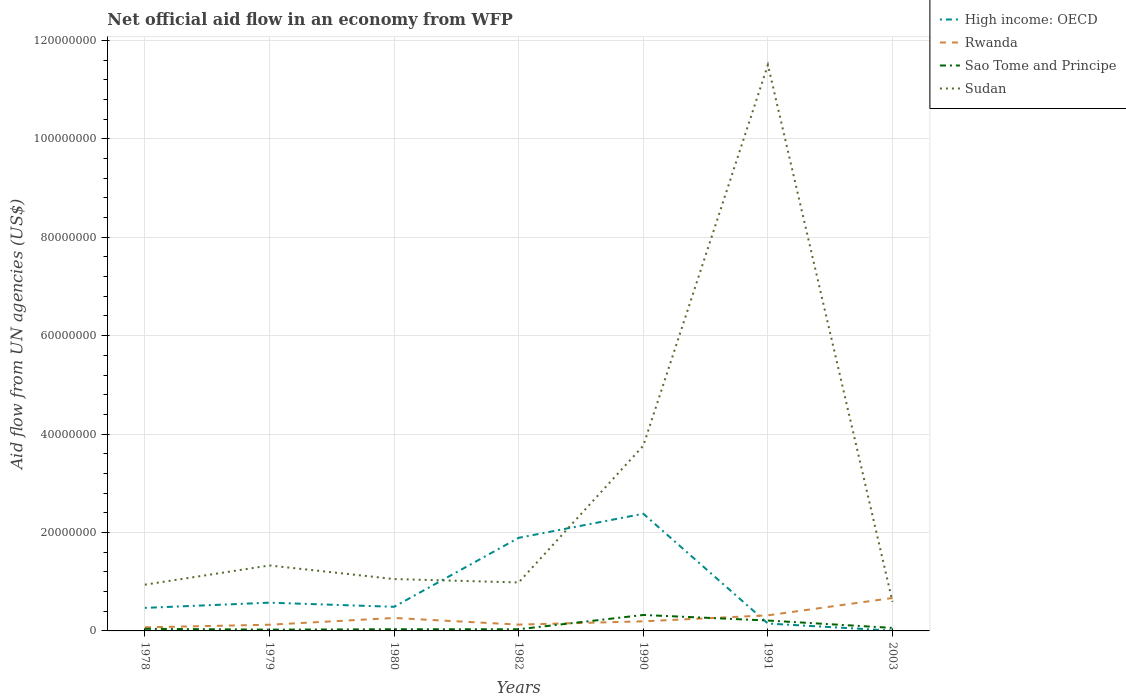How many different coloured lines are there?
Provide a short and direct response. 4. Does the line corresponding to Rwanda intersect with the line corresponding to High income: OECD?
Keep it short and to the point. Yes. Is the number of lines equal to the number of legend labels?
Your answer should be very brief. Yes. Across all years, what is the maximum net official aid flow in Sudan?
Provide a succinct answer. 5.92e+06. In which year was the net official aid flow in Sao Tome and Principe maximum?
Provide a short and direct response. 1979. What is the total net official aid flow in Rwanda in the graph?
Provide a succinct answer. -1.22e+06. What is the difference between the highest and the second highest net official aid flow in High income: OECD?
Ensure brevity in your answer.  2.38e+07. Is the net official aid flow in Sudan strictly greater than the net official aid flow in Sao Tome and Principe over the years?
Make the answer very short. No. How many lines are there?
Give a very brief answer. 4. How many years are there in the graph?
Offer a terse response. 7. Does the graph contain any zero values?
Give a very brief answer. No. Does the graph contain grids?
Offer a terse response. Yes. How many legend labels are there?
Ensure brevity in your answer.  4. How are the legend labels stacked?
Give a very brief answer. Vertical. What is the title of the graph?
Make the answer very short. Net official aid flow in an economy from WFP. What is the label or title of the X-axis?
Offer a very short reply. Years. What is the label or title of the Y-axis?
Provide a short and direct response. Aid flow from UN agencies (US$). What is the Aid flow from UN agencies (US$) in High income: OECD in 1978?
Offer a very short reply. 4.68e+06. What is the Aid flow from UN agencies (US$) of Rwanda in 1978?
Provide a short and direct response. 7.30e+05. What is the Aid flow from UN agencies (US$) in Sao Tome and Principe in 1978?
Keep it short and to the point. 4.30e+05. What is the Aid flow from UN agencies (US$) in Sudan in 1978?
Provide a succinct answer. 9.40e+06. What is the Aid flow from UN agencies (US$) in High income: OECD in 1979?
Your response must be concise. 5.74e+06. What is the Aid flow from UN agencies (US$) in Rwanda in 1979?
Your answer should be compact. 1.26e+06. What is the Aid flow from UN agencies (US$) in Sudan in 1979?
Your answer should be compact. 1.33e+07. What is the Aid flow from UN agencies (US$) of High income: OECD in 1980?
Keep it short and to the point. 4.90e+06. What is the Aid flow from UN agencies (US$) of Rwanda in 1980?
Offer a terse response. 2.63e+06. What is the Aid flow from UN agencies (US$) of Sudan in 1980?
Offer a very short reply. 1.05e+07. What is the Aid flow from UN agencies (US$) in High income: OECD in 1982?
Your answer should be very brief. 1.89e+07. What is the Aid flow from UN agencies (US$) of Rwanda in 1982?
Keep it short and to the point. 1.28e+06. What is the Aid flow from UN agencies (US$) in Sao Tome and Principe in 1982?
Keep it short and to the point. 3.40e+05. What is the Aid flow from UN agencies (US$) in Sudan in 1982?
Give a very brief answer. 9.85e+06. What is the Aid flow from UN agencies (US$) in High income: OECD in 1990?
Offer a terse response. 2.38e+07. What is the Aid flow from UN agencies (US$) in Rwanda in 1990?
Your answer should be very brief. 1.95e+06. What is the Aid flow from UN agencies (US$) of Sao Tome and Principe in 1990?
Keep it short and to the point. 3.24e+06. What is the Aid flow from UN agencies (US$) in Sudan in 1990?
Your answer should be compact. 3.76e+07. What is the Aid flow from UN agencies (US$) in High income: OECD in 1991?
Your response must be concise. 1.50e+06. What is the Aid flow from UN agencies (US$) in Rwanda in 1991?
Your response must be concise. 3.17e+06. What is the Aid flow from UN agencies (US$) in Sao Tome and Principe in 1991?
Make the answer very short. 2.11e+06. What is the Aid flow from UN agencies (US$) of Sudan in 1991?
Offer a very short reply. 1.15e+08. What is the Aid flow from UN agencies (US$) of Rwanda in 2003?
Your answer should be compact. 6.69e+06. What is the Aid flow from UN agencies (US$) of Sudan in 2003?
Give a very brief answer. 5.92e+06. Across all years, what is the maximum Aid flow from UN agencies (US$) of High income: OECD?
Provide a succinct answer. 2.38e+07. Across all years, what is the maximum Aid flow from UN agencies (US$) in Rwanda?
Ensure brevity in your answer.  6.69e+06. Across all years, what is the maximum Aid flow from UN agencies (US$) of Sao Tome and Principe?
Your answer should be very brief. 3.24e+06. Across all years, what is the maximum Aid flow from UN agencies (US$) in Sudan?
Give a very brief answer. 1.15e+08. Across all years, what is the minimum Aid flow from UN agencies (US$) in Rwanda?
Provide a short and direct response. 7.30e+05. Across all years, what is the minimum Aid flow from UN agencies (US$) of Sao Tome and Principe?
Offer a very short reply. 2.60e+05. Across all years, what is the minimum Aid flow from UN agencies (US$) in Sudan?
Give a very brief answer. 5.92e+06. What is the total Aid flow from UN agencies (US$) in High income: OECD in the graph?
Give a very brief answer. 5.96e+07. What is the total Aid flow from UN agencies (US$) of Rwanda in the graph?
Your response must be concise. 1.77e+07. What is the total Aid flow from UN agencies (US$) in Sao Tome and Principe in the graph?
Your answer should be very brief. 7.33e+06. What is the total Aid flow from UN agencies (US$) of Sudan in the graph?
Offer a terse response. 2.02e+08. What is the difference between the Aid flow from UN agencies (US$) of High income: OECD in 1978 and that in 1979?
Keep it short and to the point. -1.06e+06. What is the difference between the Aid flow from UN agencies (US$) of Rwanda in 1978 and that in 1979?
Offer a terse response. -5.30e+05. What is the difference between the Aid flow from UN agencies (US$) of Sudan in 1978 and that in 1979?
Ensure brevity in your answer.  -3.90e+06. What is the difference between the Aid flow from UN agencies (US$) in Rwanda in 1978 and that in 1980?
Provide a short and direct response. -1.90e+06. What is the difference between the Aid flow from UN agencies (US$) in Sao Tome and Principe in 1978 and that in 1980?
Ensure brevity in your answer.  9.00e+04. What is the difference between the Aid flow from UN agencies (US$) of Sudan in 1978 and that in 1980?
Offer a terse response. -1.14e+06. What is the difference between the Aid flow from UN agencies (US$) in High income: OECD in 1978 and that in 1982?
Give a very brief answer. -1.42e+07. What is the difference between the Aid flow from UN agencies (US$) in Rwanda in 1978 and that in 1982?
Keep it short and to the point. -5.50e+05. What is the difference between the Aid flow from UN agencies (US$) of Sudan in 1978 and that in 1982?
Your answer should be very brief. -4.50e+05. What is the difference between the Aid flow from UN agencies (US$) of High income: OECD in 1978 and that in 1990?
Keep it short and to the point. -1.91e+07. What is the difference between the Aid flow from UN agencies (US$) in Rwanda in 1978 and that in 1990?
Ensure brevity in your answer.  -1.22e+06. What is the difference between the Aid flow from UN agencies (US$) in Sao Tome and Principe in 1978 and that in 1990?
Ensure brevity in your answer.  -2.81e+06. What is the difference between the Aid flow from UN agencies (US$) of Sudan in 1978 and that in 1990?
Provide a succinct answer. -2.82e+07. What is the difference between the Aid flow from UN agencies (US$) in High income: OECD in 1978 and that in 1991?
Your answer should be very brief. 3.18e+06. What is the difference between the Aid flow from UN agencies (US$) in Rwanda in 1978 and that in 1991?
Give a very brief answer. -2.44e+06. What is the difference between the Aid flow from UN agencies (US$) of Sao Tome and Principe in 1978 and that in 1991?
Provide a short and direct response. -1.68e+06. What is the difference between the Aid flow from UN agencies (US$) in Sudan in 1978 and that in 1991?
Provide a succinct answer. -1.06e+08. What is the difference between the Aid flow from UN agencies (US$) of High income: OECD in 1978 and that in 2003?
Give a very brief answer. 4.62e+06. What is the difference between the Aid flow from UN agencies (US$) of Rwanda in 1978 and that in 2003?
Provide a short and direct response. -5.96e+06. What is the difference between the Aid flow from UN agencies (US$) of Sao Tome and Principe in 1978 and that in 2003?
Give a very brief answer. -1.80e+05. What is the difference between the Aid flow from UN agencies (US$) of Sudan in 1978 and that in 2003?
Your answer should be compact. 3.48e+06. What is the difference between the Aid flow from UN agencies (US$) in High income: OECD in 1979 and that in 1980?
Offer a terse response. 8.40e+05. What is the difference between the Aid flow from UN agencies (US$) of Rwanda in 1979 and that in 1980?
Your answer should be compact. -1.37e+06. What is the difference between the Aid flow from UN agencies (US$) in Sudan in 1979 and that in 1980?
Provide a succinct answer. 2.76e+06. What is the difference between the Aid flow from UN agencies (US$) of High income: OECD in 1979 and that in 1982?
Offer a very short reply. -1.32e+07. What is the difference between the Aid flow from UN agencies (US$) of Sudan in 1979 and that in 1982?
Offer a terse response. 3.45e+06. What is the difference between the Aid flow from UN agencies (US$) of High income: OECD in 1979 and that in 1990?
Your answer should be very brief. -1.81e+07. What is the difference between the Aid flow from UN agencies (US$) of Rwanda in 1979 and that in 1990?
Your answer should be compact. -6.90e+05. What is the difference between the Aid flow from UN agencies (US$) of Sao Tome and Principe in 1979 and that in 1990?
Offer a very short reply. -2.98e+06. What is the difference between the Aid flow from UN agencies (US$) of Sudan in 1979 and that in 1990?
Ensure brevity in your answer.  -2.43e+07. What is the difference between the Aid flow from UN agencies (US$) of High income: OECD in 1979 and that in 1991?
Provide a succinct answer. 4.24e+06. What is the difference between the Aid flow from UN agencies (US$) in Rwanda in 1979 and that in 1991?
Ensure brevity in your answer.  -1.91e+06. What is the difference between the Aid flow from UN agencies (US$) of Sao Tome and Principe in 1979 and that in 1991?
Give a very brief answer. -1.85e+06. What is the difference between the Aid flow from UN agencies (US$) in Sudan in 1979 and that in 1991?
Keep it short and to the point. -1.02e+08. What is the difference between the Aid flow from UN agencies (US$) of High income: OECD in 1979 and that in 2003?
Your answer should be compact. 5.68e+06. What is the difference between the Aid flow from UN agencies (US$) in Rwanda in 1979 and that in 2003?
Your answer should be compact. -5.43e+06. What is the difference between the Aid flow from UN agencies (US$) of Sao Tome and Principe in 1979 and that in 2003?
Your answer should be very brief. -3.50e+05. What is the difference between the Aid flow from UN agencies (US$) in Sudan in 1979 and that in 2003?
Your response must be concise. 7.38e+06. What is the difference between the Aid flow from UN agencies (US$) in High income: OECD in 1980 and that in 1982?
Provide a short and direct response. -1.40e+07. What is the difference between the Aid flow from UN agencies (US$) in Rwanda in 1980 and that in 1982?
Your answer should be very brief. 1.35e+06. What is the difference between the Aid flow from UN agencies (US$) in Sao Tome and Principe in 1980 and that in 1982?
Provide a succinct answer. 0. What is the difference between the Aid flow from UN agencies (US$) in Sudan in 1980 and that in 1982?
Give a very brief answer. 6.90e+05. What is the difference between the Aid flow from UN agencies (US$) in High income: OECD in 1980 and that in 1990?
Keep it short and to the point. -1.89e+07. What is the difference between the Aid flow from UN agencies (US$) of Rwanda in 1980 and that in 1990?
Your answer should be very brief. 6.80e+05. What is the difference between the Aid flow from UN agencies (US$) in Sao Tome and Principe in 1980 and that in 1990?
Keep it short and to the point. -2.90e+06. What is the difference between the Aid flow from UN agencies (US$) of Sudan in 1980 and that in 1990?
Provide a succinct answer. -2.71e+07. What is the difference between the Aid flow from UN agencies (US$) in High income: OECD in 1980 and that in 1991?
Offer a very short reply. 3.40e+06. What is the difference between the Aid flow from UN agencies (US$) of Rwanda in 1980 and that in 1991?
Your response must be concise. -5.40e+05. What is the difference between the Aid flow from UN agencies (US$) in Sao Tome and Principe in 1980 and that in 1991?
Your answer should be compact. -1.77e+06. What is the difference between the Aid flow from UN agencies (US$) of Sudan in 1980 and that in 1991?
Your answer should be very brief. -1.04e+08. What is the difference between the Aid flow from UN agencies (US$) of High income: OECD in 1980 and that in 2003?
Your answer should be compact. 4.84e+06. What is the difference between the Aid flow from UN agencies (US$) in Rwanda in 1980 and that in 2003?
Make the answer very short. -4.06e+06. What is the difference between the Aid flow from UN agencies (US$) in Sudan in 1980 and that in 2003?
Your answer should be compact. 4.62e+06. What is the difference between the Aid flow from UN agencies (US$) in High income: OECD in 1982 and that in 1990?
Give a very brief answer. -4.89e+06. What is the difference between the Aid flow from UN agencies (US$) in Rwanda in 1982 and that in 1990?
Provide a short and direct response. -6.70e+05. What is the difference between the Aid flow from UN agencies (US$) of Sao Tome and Principe in 1982 and that in 1990?
Give a very brief answer. -2.90e+06. What is the difference between the Aid flow from UN agencies (US$) in Sudan in 1982 and that in 1990?
Give a very brief answer. -2.78e+07. What is the difference between the Aid flow from UN agencies (US$) of High income: OECD in 1982 and that in 1991?
Your answer should be compact. 1.74e+07. What is the difference between the Aid flow from UN agencies (US$) in Rwanda in 1982 and that in 1991?
Your response must be concise. -1.89e+06. What is the difference between the Aid flow from UN agencies (US$) of Sao Tome and Principe in 1982 and that in 1991?
Your answer should be compact. -1.77e+06. What is the difference between the Aid flow from UN agencies (US$) in Sudan in 1982 and that in 1991?
Your response must be concise. -1.05e+08. What is the difference between the Aid flow from UN agencies (US$) of High income: OECD in 1982 and that in 2003?
Provide a short and direct response. 1.89e+07. What is the difference between the Aid flow from UN agencies (US$) in Rwanda in 1982 and that in 2003?
Your answer should be very brief. -5.41e+06. What is the difference between the Aid flow from UN agencies (US$) in Sudan in 1982 and that in 2003?
Offer a terse response. 3.93e+06. What is the difference between the Aid flow from UN agencies (US$) in High income: OECD in 1990 and that in 1991?
Keep it short and to the point. 2.23e+07. What is the difference between the Aid flow from UN agencies (US$) in Rwanda in 1990 and that in 1991?
Offer a terse response. -1.22e+06. What is the difference between the Aid flow from UN agencies (US$) in Sao Tome and Principe in 1990 and that in 1991?
Offer a very short reply. 1.13e+06. What is the difference between the Aid flow from UN agencies (US$) in Sudan in 1990 and that in 1991?
Your response must be concise. -7.74e+07. What is the difference between the Aid flow from UN agencies (US$) of High income: OECD in 1990 and that in 2003?
Ensure brevity in your answer.  2.38e+07. What is the difference between the Aid flow from UN agencies (US$) in Rwanda in 1990 and that in 2003?
Make the answer very short. -4.74e+06. What is the difference between the Aid flow from UN agencies (US$) in Sao Tome and Principe in 1990 and that in 2003?
Your answer should be compact. 2.63e+06. What is the difference between the Aid flow from UN agencies (US$) of Sudan in 1990 and that in 2003?
Ensure brevity in your answer.  3.17e+07. What is the difference between the Aid flow from UN agencies (US$) in High income: OECD in 1991 and that in 2003?
Provide a succinct answer. 1.44e+06. What is the difference between the Aid flow from UN agencies (US$) in Rwanda in 1991 and that in 2003?
Offer a very short reply. -3.52e+06. What is the difference between the Aid flow from UN agencies (US$) of Sao Tome and Principe in 1991 and that in 2003?
Your answer should be very brief. 1.50e+06. What is the difference between the Aid flow from UN agencies (US$) in Sudan in 1991 and that in 2003?
Keep it short and to the point. 1.09e+08. What is the difference between the Aid flow from UN agencies (US$) of High income: OECD in 1978 and the Aid flow from UN agencies (US$) of Rwanda in 1979?
Make the answer very short. 3.42e+06. What is the difference between the Aid flow from UN agencies (US$) of High income: OECD in 1978 and the Aid flow from UN agencies (US$) of Sao Tome and Principe in 1979?
Ensure brevity in your answer.  4.42e+06. What is the difference between the Aid flow from UN agencies (US$) in High income: OECD in 1978 and the Aid flow from UN agencies (US$) in Sudan in 1979?
Provide a succinct answer. -8.62e+06. What is the difference between the Aid flow from UN agencies (US$) in Rwanda in 1978 and the Aid flow from UN agencies (US$) in Sudan in 1979?
Your answer should be compact. -1.26e+07. What is the difference between the Aid flow from UN agencies (US$) in Sao Tome and Principe in 1978 and the Aid flow from UN agencies (US$) in Sudan in 1979?
Your answer should be very brief. -1.29e+07. What is the difference between the Aid flow from UN agencies (US$) in High income: OECD in 1978 and the Aid flow from UN agencies (US$) in Rwanda in 1980?
Your response must be concise. 2.05e+06. What is the difference between the Aid flow from UN agencies (US$) in High income: OECD in 1978 and the Aid flow from UN agencies (US$) in Sao Tome and Principe in 1980?
Your answer should be very brief. 4.34e+06. What is the difference between the Aid flow from UN agencies (US$) of High income: OECD in 1978 and the Aid flow from UN agencies (US$) of Sudan in 1980?
Ensure brevity in your answer.  -5.86e+06. What is the difference between the Aid flow from UN agencies (US$) of Rwanda in 1978 and the Aid flow from UN agencies (US$) of Sao Tome and Principe in 1980?
Give a very brief answer. 3.90e+05. What is the difference between the Aid flow from UN agencies (US$) in Rwanda in 1978 and the Aid flow from UN agencies (US$) in Sudan in 1980?
Provide a succinct answer. -9.81e+06. What is the difference between the Aid flow from UN agencies (US$) of Sao Tome and Principe in 1978 and the Aid flow from UN agencies (US$) of Sudan in 1980?
Offer a very short reply. -1.01e+07. What is the difference between the Aid flow from UN agencies (US$) of High income: OECD in 1978 and the Aid flow from UN agencies (US$) of Rwanda in 1982?
Your response must be concise. 3.40e+06. What is the difference between the Aid flow from UN agencies (US$) in High income: OECD in 1978 and the Aid flow from UN agencies (US$) in Sao Tome and Principe in 1982?
Offer a very short reply. 4.34e+06. What is the difference between the Aid flow from UN agencies (US$) in High income: OECD in 1978 and the Aid flow from UN agencies (US$) in Sudan in 1982?
Make the answer very short. -5.17e+06. What is the difference between the Aid flow from UN agencies (US$) in Rwanda in 1978 and the Aid flow from UN agencies (US$) in Sudan in 1982?
Your response must be concise. -9.12e+06. What is the difference between the Aid flow from UN agencies (US$) in Sao Tome and Principe in 1978 and the Aid flow from UN agencies (US$) in Sudan in 1982?
Provide a succinct answer. -9.42e+06. What is the difference between the Aid flow from UN agencies (US$) in High income: OECD in 1978 and the Aid flow from UN agencies (US$) in Rwanda in 1990?
Provide a succinct answer. 2.73e+06. What is the difference between the Aid flow from UN agencies (US$) in High income: OECD in 1978 and the Aid flow from UN agencies (US$) in Sao Tome and Principe in 1990?
Give a very brief answer. 1.44e+06. What is the difference between the Aid flow from UN agencies (US$) of High income: OECD in 1978 and the Aid flow from UN agencies (US$) of Sudan in 1990?
Ensure brevity in your answer.  -3.30e+07. What is the difference between the Aid flow from UN agencies (US$) of Rwanda in 1978 and the Aid flow from UN agencies (US$) of Sao Tome and Principe in 1990?
Give a very brief answer. -2.51e+06. What is the difference between the Aid flow from UN agencies (US$) of Rwanda in 1978 and the Aid flow from UN agencies (US$) of Sudan in 1990?
Your response must be concise. -3.69e+07. What is the difference between the Aid flow from UN agencies (US$) of Sao Tome and Principe in 1978 and the Aid flow from UN agencies (US$) of Sudan in 1990?
Give a very brief answer. -3.72e+07. What is the difference between the Aid flow from UN agencies (US$) of High income: OECD in 1978 and the Aid flow from UN agencies (US$) of Rwanda in 1991?
Offer a terse response. 1.51e+06. What is the difference between the Aid flow from UN agencies (US$) in High income: OECD in 1978 and the Aid flow from UN agencies (US$) in Sao Tome and Principe in 1991?
Provide a short and direct response. 2.57e+06. What is the difference between the Aid flow from UN agencies (US$) in High income: OECD in 1978 and the Aid flow from UN agencies (US$) in Sudan in 1991?
Make the answer very short. -1.10e+08. What is the difference between the Aid flow from UN agencies (US$) in Rwanda in 1978 and the Aid flow from UN agencies (US$) in Sao Tome and Principe in 1991?
Your answer should be very brief. -1.38e+06. What is the difference between the Aid flow from UN agencies (US$) in Rwanda in 1978 and the Aid flow from UN agencies (US$) in Sudan in 1991?
Provide a short and direct response. -1.14e+08. What is the difference between the Aid flow from UN agencies (US$) of Sao Tome and Principe in 1978 and the Aid flow from UN agencies (US$) of Sudan in 1991?
Your response must be concise. -1.15e+08. What is the difference between the Aid flow from UN agencies (US$) of High income: OECD in 1978 and the Aid flow from UN agencies (US$) of Rwanda in 2003?
Your answer should be compact. -2.01e+06. What is the difference between the Aid flow from UN agencies (US$) in High income: OECD in 1978 and the Aid flow from UN agencies (US$) in Sao Tome and Principe in 2003?
Give a very brief answer. 4.07e+06. What is the difference between the Aid flow from UN agencies (US$) in High income: OECD in 1978 and the Aid flow from UN agencies (US$) in Sudan in 2003?
Your answer should be compact. -1.24e+06. What is the difference between the Aid flow from UN agencies (US$) in Rwanda in 1978 and the Aid flow from UN agencies (US$) in Sao Tome and Principe in 2003?
Offer a very short reply. 1.20e+05. What is the difference between the Aid flow from UN agencies (US$) in Rwanda in 1978 and the Aid flow from UN agencies (US$) in Sudan in 2003?
Your response must be concise. -5.19e+06. What is the difference between the Aid flow from UN agencies (US$) of Sao Tome and Principe in 1978 and the Aid flow from UN agencies (US$) of Sudan in 2003?
Offer a very short reply. -5.49e+06. What is the difference between the Aid flow from UN agencies (US$) of High income: OECD in 1979 and the Aid flow from UN agencies (US$) of Rwanda in 1980?
Provide a succinct answer. 3.11e+06. What is the difference between the Aid flow from UN agencies (US$) in High income: OECD in 1979 and the Aid flow from UN agencies (US$) in Sao Tome and Principe in 1980?
Make the answer very short. 5.40e+06. What is the difference between the Aid flow from UN agencies (US$) of High income: OECD in 1979 and the Aid flow from UN agencies (US$) of Sudan in 1980?
Provide a succinct answer. -4.80e+06. What is the difference between the Aid flow from UN agencies (US$) in Rwanda in 1979 and the Aid flow from UN agencies (US$) in Sao Tome and Principe in 1980?
Give a very brief answer. 9.20e+05. What is the difference between the Aid flow from UN agencies (US$) of Rwanda in 1979 and the Aid flow from UN agencies (US$) of Sudan in 1980?
Give a very brief answer. -9.28e+06. What is the difference between the Aid flow from UN agencies (US$) in Sao Tome and Principe in 1979 and the Aid flow from UN agencies (US$) in Sudan in 1980?
Make the answer very short. -1.03e+07. What is the difference between the Aid flow from UN agencies (US$) in High income: OECD in 1979 and the Aid flow from UN agencies (US$) in Rwanda in 1982?
Give a very brief answer. 4.46e+06. What is the difference between the Aid flow from UN agencies (US$) in High income: OECD in 1979 and the Aid flow from UN agencies (US$) in Sao Tome and Principe in 1982?
Your answer should be compact. 5.40e+06. What is the difference between the Aid flow from UN agencies (US$) of High income: OECD in 1979 and the Aid flow from UN agencies (US$) of Sudan in 1982?
Keep it short and to the point. -4.11e+06. What is the difference between the Aid flow from UN agencies (US$) in Rwanda in 1979 and the Aid flow from UN agencies (US$) in Sao Tome and Principe in 1982?
Your response must be concise. 9.20e+05. What is the difference between the Aid flow from UN agencies (US$) in Rwanda in 1979 and the Aid flow from UN agencies (US$) in Sudan in 1982?
Ensure brevity in your answer.  -8.59e+06. What is the difference between the Aid flow from UN agencies (US$) of Sao Tome and Principe in 1979 and the Aid flow from UN agencies (US$) of Sudan in 1982?
Keep it short and to the point. -9.59e+06. What is the difference between the Aid flow from UN agencies (US$) in High income: OECD in 1979 and the Aid flow from UN agencies (US$) in Rwanda in 1990?
Ensure brevity in your answer.  3.79e+06. What is the difference between the Aid flow from UN agencies (US$) in High income: OECD in 1979 and the Aid flow from UN agencies (US$) in Sao Tome and Principe in 1990?
Your answer should be compact. 2.50e+06. What is the difference between the Aid flow from UN agencies (US$) in High income: OECD in 1979 and the Aid flow from UN agencies (US$) in Sudan in 1990?
Your answer should be very brief. -3.19e+07. What is the difference between the Aid flow from UN agencies (US$) of Rwanda in 1979 and the Aid flow from UN agencies (US$) of Sao Tome and Principe in 1990?
Your response must be concise. -1.98e+06. What is the difference between the Aid flow from UN agencies (US$) of Rwanda in 1979 and the Aid flow from UN agencies (US$) of Sudan in 1990?
Your answer should be very brief. -3.64e+07. What is the difference between the Aid flow from UN agencies (US$) of Sao Tome and Principe in 1979 and the Aid flow from UN agencies (US$) of Sudan in 1990?
Your answer should be very brief. -3.74e+07. What is the difference between the Aid flow from UN agencies (US$) in High income: OECD in 1979 and the Aid flow from UN agencies (US$) in Rwanda in 1991?
Your answer should be compact. 2.57e+06. What is the difference between the Aid flow from UN agencies (US$) in High income: OECD in 1979 and the Aid flow from UN agencies (US$) in Sao Tome and Principe in 1991?
Keep it short and to the point. 3.63e+06. What is the difference between the Aid flow from UN agencies (US$) of High income: OECD in 1979 and the Aid flow from UN agencies (US$) of Sudan in 1991?
Your response must be concise. -1.09e+08. What is the difference between the Aid flow from UN agencies (US$) in Rwanda in 1979 and the Aid flow from UN agencies (US$) in Sao Tome and Principe in 1991?
Provide a short and direct response. -8.50e+05. What is the difference between the Aid flow from UN agencies (US$) of Rwanda in 1979 and the Aid flow from UN agencies (US$) of Sudan in 1991?
Give a very brief answer. -1.14e+08. What is the difference between the Aid flow from UN agencies (US$) in Sao Tome and Principe in 1979 and the Aid flow from UN agencies (US$) in Sudan in 1991?
Your answer should be compact. -1.15e+08. What is the difference between the Aid flow from UN agencies (US$) in High income: OECD in 1979 and the Aid flow from UN agencies (US$) in Rwanda in 2003?
Ensure brevity in your answer.  -9.50e+05. What is the difference between the Aid flow from UN agencies (US$) of High income: OECD in 1979 and the Aid flow from UN agencies (US$) of Sao Tome and Principe in 2003?
Keep it short and to the point. 5.13e+06. What is the difference between the Aid flow from UN agencies (US$) of High income: OECD in 1979 and the Aid flow from UN agencies (US$) of Sudan in 2003?
Your answer should be compact. -1.80e+05. What is the difference between the Aid flow from UN agencies (US$) in Rwanda in 1979 and the Aid flow from UN agencies (US$) in Sao Tome and Principe in 2003?
Keep it short and to the point. 6.50e+05. What is the difference between the Aid flow from UN agencies (US$) in Rwanda in 1979 and the Aid flow from UN agencies (US$) in Sudan in 2003?
Your response must be concise. -4.66e+06. What is the difference between the Aid flow from UN agencies (US$) of Sao Tome and Principe in 1979 and the Aid flow from UN agencies (US$) of Sudan in 2003?
Give a very brief answer. -5.66e+06. What is the difference between the Aid flow from UN agencies (US$) of High income: OECD in 1980 and the Aid flow from UN agencies (US$) of Rwanda in 1982?
Your answer should be very brief. 3.62e+06. What is the difference between the Aid flow from UN agencies (US$) in High income: OECD in 1980 and the Aid flow from UN agencies (US$) in Sao Tome and Principe in 1982?
Keep it short and to the point. 4.56e+06. What is the difference between the Aid flow from UN agencies (US$) in High income: OECD in 1980 and the Aid flow from UN agencies (US$) in Sudan in 1982?
Your response must be concise. -4.95e+06. What is the difference between the Aid flow from UN agencies (US$) in Rwanda in 1980 and the Aid flow from UN agencies (US$) in Sao Tome and Principe in 1982?
Your answer should be compact. 2.29e+06. What is the difference between the Aid flow from UN agencies (US$) in Rwanda in 1980 and the Aid flow from UN agencies (US$) in Sudan in 1982?
Provide a succinct answer. -7.22e+06. What is the difference between the Aid flow from UN agencies (US$) of Sao Tome and Principe in 1980 and the Aid flow from UN agencies (US$) of Sudan in 1982?
Provide a succinct answer. -9.51e+06. What is the difference between the Aid flow from UN agencies (US$) in High income: OECD in 1980 and the Aid flow from UN agencies (US$) in Rwanda in 1990?
Provide a short and direct response. 2.95e+06. What is the difference between the Aid flow from UN agencies (US$) in High income: OECD in 1980 and the Aid flow from UN agencies (US$) in Sao Tome and Principe in 1990?
Provide a succinct answer. 1.66e+06. What is the difference between the Aid flow from UN agencies (US$) in High income: OECD in 1980 and the Aid flow from UN agencies (US$) in Sudan in 1990?
Provide a short and direct response. -3.27e+07. What is the difference between the Aid flow from UN agencies (US$) in Rwanda in 1980 and the Aid flow from UN agencies (US$) in Sao Tome and Principe in 1990?
Offer a terse response. -6.10e+05. What is the difference between the Aid flow from UN agencies (US$) of Rwanda in 1980 and the Aid flow from UN agencies (US$) of Sudan in 1990?
Your response must be concise. -3.50e+07. What is the difference between the Aid flow from UN agencies (US$) of Sao Tome and Principe in 1980 and the Aid flow from UN agencies (US$) of Sudan in 1990?
Your answer should be compact. -3.73e+07. What is the difference between the Aid flow from UN agencies (US$) of High income: OECD in 1980 and the Aid flow from UN agencies (US$) of Rwanda in 1991?
Give a very brief answer. 1.73e+06. What is the difference between the Aid flow from UN agencies (US$) of High income: OECD in 1980 and the Aid flow from UN agencies (US$) of Sao Tome and Principe in 1991?
Ensure brevity in your answer.  2.79e+06. What is the difference between the Aid flow from UN agencies (US$) in High income: OECD in 1980 and the Aid flow from UN agencies (US$) in Sudan in 1991?
Ensure brevity in your answer.  -1.10e+08. What is the difference between the Aid flow from UN agencies (US$) of Rwanda in 1980 and the Aid flow from UN agencies (US$) of Sao Tome and Principe in 1991?
Provide a short and direct response. 5.20e+05. What is the difference between the Aid flow from UN agencies (US$) of Rwanda in 1980 and the Aid flow from UN agencies (US$) of Sudan in 1991?
Ensure brevity in your answer.  -1.12e+08. What is the difference between the Aid flow from UN agencies (US$) of Sao Tome and Principe in 1980 and the Aid flow from UN agencies (US$) of Sudan in 1991?
Your answer should be compact. -1.15e+08. What is the difference between the Aid flow from UN agencies (US$) in High income: OECD in 1980 and the Aid flow from UN agencies (US$) in Rwanda in 2003?
Provide a succinct answer. -1.79e+06. What is the difference between the Aid flow from UN agencies (US$) of High income: OECD in 1980 and the Aid flow from UN agencies (US$) of Sao Tome and Principe in 2003?
Offer a terse response. 4.29e+06. What is the difference between the Aid flow from UN agencies (US$) of High income: OECD in 1980 and the Aid flow from UN agencies (US$) of Sudan in 2003?
Keep it short and to the point. -1.02e+06. What is the difference between the Aid flow from UN agencies (US$) of Rwanda in 1980 and the Aid flow from UN agencies (US$) of Sao Tome and Principe in 2003?
Give a very brief answer. 2.02e+06. What is the difference between the Aid flow from UN agencies (US$) in Rwanda in 1980 and the Aid flow from UN agencies (US$) in Sudan in 2003?
Ensure brevity in your answer.  -3.29e+06. What is the difference between the Aid flow from UN agencies (US$) of Sao Tome and Principe in 1980 and the Aid flow from UN agencies (US$) of Sudan in 2003?
Ensure brevity in your answer.  -5.58e+06. What is the difference between the Aid flow from UN agencies (US$) of High income: OECD in 1982 and the Aid flow from UN agencies (US$) of Rwanda in 1990?
Keep it short and to the point. 1.70e+07. What is the difference between the Aid flow from UN agencies (US$) of High income: OECD in 1982 and the Aid flow from UN agencies (US$) of Sao Tome and Principe in 1990?
Make the answer very short. 1.57e+07. What is the difference between the Aid flow from UN agencies (US$) in High income: OECD in 1982 and the Aid flow from UN agencies (US$) in Sudan in 1990?
Offer a terse response. -1.87e+07. What is the difference between the Aid flow from UN agencies (US$) of Rwanda in 1982 and the Aid flow from UN agencies (US$) of Sao Tome and Principe in 1990?
Make the answer very short. -1.96e+06. What is the difference between the Aid flow from UN agencies (US$) of Rwanda in 1982 and the Aid flow from UN agencies (US$) of Sudan in 1990?
Give a very brief answer. -3.64e+07. What is the difference between the Aid flow from UN agencies (US$) of Sao Tome and Principe in 1982 and the Aid flow from UN agencies (US$) of Sudan in 1990?
Provide a short and direct response. -3.73e+07. What is the difference between the Aid flow from UN agencies (US$) in High income: OECD in 1982 and the Aid flow from UN agencies (US$) in Rwanda in 1991?
Your answer should be very brief. 1.58e+07. What is the difference between the Aid flow from UN agencies (US$) in High income: OECD in 1982 and the Aid flow from UN agencies (US$) in Sao Tome and Principe in 1991?
Your answer should be very brief. 1.68e+07. What is the difference between the Aid flow from UN agencies (US$) in High income: OECD in 1982 and the Aid flow from UN agencies (US$) in Sudan in 1991?
Your response must be concise. -9.61e+07. What is the difference between the Aid flow from UN agencies (US$) in Rwanda in 1982 and the Aid flow from UN agencies (US$) in Sao Tome and Principe in 1991?
Your answer should be compact. -8.30e+05. What is the difference between the Aid flow from UN agencies (US$) in Rwanda in 1982 and the Aid flow from UN agencies (US$) in Sudan in 1991?
Your response must be concise. -1.14e+08. What is the difference between the Aid flow from UN agencies (US$) of Sao Tome and Principe in 1982 and the Aid flow from UN agencies (US$) of Sudan in 1991?
Keep it short and to the point. -1.15e+08. What is the difference between the Aid flow from UN agencies (US$) in High income: OECD in 1982 and the Aid flow from UN agencies (US$) in Rwanda in 2003?
Your response must be concise. 1.22e+07. What is the difference between the Aid flow from UN agencies (US$) of High income: OECD in 1982 and the Aid flow from UN agencies (US$) of Sao Tome and Principe in 2003?
Offer a very short reply. 1.83e+07. What is the difference between the Aid flow from UN agencies (US$) in High income: OECD in 1982 and the Aid flow from UN agencies (US$) in Sudan in 2003?
Provide a succinct answer. 1.30e+07. What is the difference between the Aid flow from UN agencies (US$) in Rwanda in 1982 and the Aid flow from UN agencies (US$) in Sao Tome and Principe in 2003?
Your response must be concise. 6.70e+05. What is the difference between the Aid flow from UN agencies (US$) in Rwanda in 1982 and the Aid flow from UN agencies (US$) in Sudan in 2003?
Ensure brevity in your answer.  -4.64e+06. What is the difference between the Aid flow from UN agencies (US$) of Sao Tome and Principe in 1982 and the Aid flow from UN agencies (US$) of Sudan in 2003?
Give a very brief answer. -5.58e+06. What is the difference between the Aid flow from UN agencies (US$) in High income: OECD in 1990 and the Aid flow from UN agencies (US$) in Rwanda in 1991?
Your answer should be compact. 2.06e+07. What is the difference between the Aid flow from UN agencies (US$) in High income: OECD in 1990 and the Aid flow from UN agencies (US$) in Sao Tome and Principe in 1991?
Give a very brief answer. 2.17e+07. What is the difference between the Aid flow from UN agencies (US$) in High income: OECD in 1990 and the Aid flow from UN agencies (US$) in Sudan in 1991?
Provide a short and direct response. -9.12e+07. What is the difference between the Aid flow from UN agencies (US$) in Rwanda in 1990 and the Aid flow from UN agencies (US$) in Sao Tome and Principe in 1991?
Provide a short and direct response. -1.60e+05. What is the difference between the Aid flow from UN agencies (US$) of Rwanda in 1990 and the Aid flow from UN agencies (US$) of Sudan in 1991?
Your response must be concise. -1.13e+08. What is the difference between the Aid flow from UN agencies (US$) of Sao Tome and Principe in 1990 and the Aid flow from UN agencies (US$) of Sudan in 1991?
Keep it short and to the point. -1.12e+08. What is the difference between the Aid flow from UN agencies (US$) in High income: OECD in 1990 and the Aid flow from UN agencies (US$) in Rwanda in 2003?
Your answer should be compact. 1.71e+07. What is the difference between the Aid flow from UN agencies (US$) of High income: OECD in 1990 and the Aid flow from UN agencies (US$) of Sao Tome and Principe in 2003?
Make the answer very short. 2.32e+07. What is the difference between the Aid flow from UN agencies (US$) in High income: OECD in 1990 and the Aid flow from UN agencies (US$) in Sudan in 2003?
Provide a succinct answer. 1.79e+07. What is the difference between the Aid flow from UN agencies (US$) of Rwanda in 1990 and the Aid flow from UN agencies (US$) of Sao Tome and Principe in 2003?
Ensure brevity in your answer.  1.34e+06. What is the difference between the Aid flow from UN agencies (US$) in Rwanda in 1990 and the Aid flow from UN agencies (US$) in Sudan in 2003?
Make the answer very short. -3.97e+06. What is the difference between the Aid flow from UN agencies (US$) of Sao Tome and Principe in 1990 and the Aid flow from UN agencies (US$) of Sudan in 2003?
Keep it short and to the point. -2.68e+06. What is the difference between the Aid flow from UN agencies (US$) in High income: OECD in 1991 and the Aid flow from UN agencies (US$) in Rwanda in 2003?
Offer a very short reply. -5.19e+06. What is the difference between the Aid flow from UN agencies (US$) of High income: OECD in 1991 and the Aid flow from UN agencies (US$) of Sao Tome and Principe in 2003?
Your response must be concise. 8.90e+05. What is the difference between the Aid flow from UN agencies (US$) in High income: OECD in 1991 and the Aid flow from UN agencies (US$) in Sudan in 2003?
Your response must be concise. -4.42e+06. What is the difference between the Aid flow from UN agencies (US$) in Rwanda in 1991 and the Aid flow from UN agencies (US$) in Sao Tome and Principe in 2003?
Your answer should be compact. 2.56e+06. What is the difference between the Aid flow from UN agencies (US$) of Rwanda in 1991 and the Aid flow from UN agencies (US$) of Sudan in 2003?
Provide a short and direct response. -2.75e+06. What is the difference between the Aid flow from UN agencies (US$) of Sao Tome and Principe in 1991 and the Aid flow from UN agencies (US$) of Sudan in 2003?
Make the answer very short. -3.81e+06. What is the average Aid flow from UN agencies (US$) in High income: OECD per year?
Your answer should be compact. 8.52e+06. What is the average Aid flow from UN agencies (US$) of Rwanda per year?
Provide a short and direct response. 2.53e+06. What is the average Aid flow from UN agencies (US$) of Sao Tome and Principe per year?
Provide a short and direct response. 1.05e+06. What is the average Aid flow from UN agencies (US$) of Sudan per year?
Ensure brevity in your answer.  2.88e+07. In the year 1978, what is the difference between the Aid flow from UN agencies (US$) of High income: OECD and Aid flow from UN agencies (US$) of Rwanda?
Your answer should be compact. 3.95e+06. In the year 1978, what is the difference between the Aid flow from UN agencies (US$) of High income: OECD and Aid flow from UN agencies (US$) of Sao Tome and Principe?
Provide a succinct answer. 4.25e+06. In the year 1978, what is the difference between the Aid flow from UN agencies (US$) in High income: OECD and Aid flow from UN agencies (US$) in Sudan?
Provide a short and direct response. -4.72e+06. In the year 1978, what is the difference between the Aid flow from UN agencies (US$) of Rwanda and Aid flow from UN agencies (US$) of Sudan?
Offer a very short reply. -8.67e+06. In the year 1978, what is the difference between the Aid flow from UN agencies (US$) in Sao Tome and Principe and Aid flow from UN agencies (US$) in Sudan?
Provide a succinct answer. -8.97e+06. In the year 1979, what is the difference between the Aid flow from UN agencies (US$) of High income: OECD and Aid flow from UN agencies (US$) of Rwanda?
Your response must be concise. 4.48e+06. In the year 1979, what is the difference between the Aid flow from UN agencies (US$) of High income: OECD and Aid flow from UN agencies (US$) of Sao Tome and Principe?
Keep it short and to the point. 5.48e+06. In the year 1979, what is the difference between the Aid flow from UN agencies (US$) of High income: OECD and Aid flow from UN agencies (US$) of Sudan?
Your answer should be compact. -7.56e+06. In the year 1979, what is the difference between the Aid flow from UN agencies (US$) of Rwanda and Aid flow from UN agencies (US$) of Sao Tome and Principe?
Ensure brevity in your answer.  1.00e+06. In the year 1979, what is the difference between the Aid flow from UN agencies (US$) of Rwanda and Aid flow from UN agencies (US$) of Sudan?
Give a very brief answer. -1.20e+07. In the year 1979, what is the difference between the Aid flow from UN agencies (US$) of Sao Tome and Principe and Aid flow from UN agencies (US$) of Sudan?
Your answer should be very brief. -1.30e+07. In the year 1980, what is the difference between the Aid flow from UN agencies (US$) in High income: OECD and Aid flow from UN agencies (US$) in Rwanda?
Keep it short and to the point. 2.27e+06. In the year 1980, what is the difference between the Aid flow from UN agencies (US$) in High income: OECD and Aid flow from UN agencies (US$) in Sao Tome and Principe?
Make the answer very short. 4.56e+06. In the year 1980, what is the difference between the Aid flow from UN agencies (US$) of High income: OECD and Aid flow from UN agencies (US$) of Sudan?
Your answer should be compact. -5.64e+06. In the year 1980, what is the difference between the Aid flow from UN agencies (US$) in Rwanda and Aid flow from UN agencies (US$) in Sao Tome and Principe?
Your response must be concise. 2.29e+06. In the year 1980, what is the difference between the Aid flow from UN agencies (US$) of Rwanda and Aid flow from UN agencies (US$) of Sudan?
Keep it short and to the point. -7.91e+06. In the year 1980, what is the difference between the Aid flow from UN agencies (US$) of Sao Tome and Principe and Aid flow from UN agencies (US$) of Sudan?
Give a very brief answer. -1.02e+07. In the year 1982, what is the difference between the Aid flow from UN agencies (US$) in High income: OECD and Aid flow from UN agencies (US$) in Rwanda?
Provide a short and direct response. 1.76e+07. In the year 1982, what is the difference between the Aid flow from UN agencies (US$) of High income: OECD and Aid flow from UN agencies (US$) of Sao Tome and Principe?
Provide a succinct answer. 1.86e+07. In the year 1982, what is the difference between the Aid flow from UN agencies (US$) of High income: OECD and Aid flow from UN agencies (US$) of Sudan?
Give a very brief answer. 9.07e+06. In the year 1982, what is the difference between the Aid flow from UN agencies (US$) in Rwanda and Aid flow from UN agencies (US$) in Sao Tome and Principe?
Keep it short and to the point. 9.40e+05. In the year 1982, what is the difference between the Aid flow from UN agencies (US$) of Rwanda and Aid flow from UN agencies (US$) of Sudan?
Offer a terse response. -8.57e+06. In the year 1982, what is the difference between the Aid flow from UN agencies (US$) of Sao Tome and Principe and Aid flow from UN agencies (US$) of Sudan?
Offer a terse response. -9.51e+06. In the year 1990, what is the difference between the Aid flow from UN agencies (US$) of High income: OECD and Aid flow from UN agencies (US$) of Rwanda?
Offer a very short reply. 2.19e+07. In the year 1990, what is the difference between the Aid flow from UN agencies (US$) in High income: OECD and Aid flow from UN agencies (US$) in Sao Tome and Principe?
Offer a very short reply. 2.06e+07. In the year 1990, what is the difference between the Aid flow from UN agencies (US$) in High income: OECD and Aid flow from UN agencies (US$) in Sudan?
Your answer should be compact. -1.38e+07. In the year 1990, what is the difference between the Aid flow from UN agencies (US$) of Rwanda and Aid flow from UN agencies (US$) of Sao Tome and Principe?
Offer a very short reply. -1.29e+06. In the year 1990, what is the difference between the Aid flow from UN agencies (US$) in Rwanda and Aid flow from UN agencies (US$) in Sudan?
Offer a terse response. -3.57e+07. In the year 1990, what is the difference between the Aid flow from UN agencies (US$) of Sao Tome and Principe and Aid flow from UN agencies (US$) of Sudan?
Your answer should be very brief. -3.44e+07. In the year 1991, what is the difference between the Aid flow from UN agencies (US$) of High income: OECD and Aid flow from UN agencies (US$) of Rwanda?
Offer a very short reply. -1.67e+06. In the year 1991, what is the difference between the Aid flow from UN agencies (US$) of High income: OECD and Aid flow from UN agencies (US$) of Sao Tome and Principe?
Provide a short and direct response. -6.10e+05. In the year 1991, what is the difference between the Aid flow from UN agencies (US$) of High income: OECD and Aid flow from UN agencies (US$) of Sudan?
Ensure brevity in your answer.  -1.14e+08. In the year 1991, what is the difference between the Aid flow from UN agencies (US$) of Rwanda and Aid flow from UN agencies (US$) of Sao Tome and Principe?
Your answer should be compact. 1.06e+06. In the year 1991, what is the difference between the Aid flow from UN agencies (US$) of Rwanda and Aid flow from UN agencies (US$) of Sudan?
Make the answer very short. -1.12e+08. In the year 1991, what is the difference between the Aid flow from UN agencies (US$) of Sao Tome and Principe and Aid flow from UN agencies (US$) of Sudan?
Your response must be concise. -1.13e+08. In the year 2003, what is the difference between the Aid flow from UN agencies (US$) in High income: OECD and Aid flow from UN agencies (US$) in Rwanda?
Keep it short and to the point. -6.63e+06. In the year 2003, what is the difference between the Aid flow from UN agencies (US$) in High income: OECD and Aid flow from UN agencies (US$) in Sao Tome and Principe?
Your response must be concise. -5.50e+05. In the year 2003, what is the difference between the Aid flow from UN agencies (US$) of High income: OECD and Aid flow from UN agencies (US$) of Sudan?
Give a very brief answer. -5.86e+06. In the year 2003, what is the difference between the Aid flow from UN agencies (US$) of Rwanda and Aid flow from UN agencies (US$) of Sao Tome and Principe?
Offer a terse response. 6.08e+06. In the year 2003, what is the difference between the Aid flow from UN agencies (US$) of Rwanda and Aid flow from UN agencies (US$) of Sudan?
Your response must be concise. 7.70e+05. In the year 2003, what is the difference between the Aid flow from UN agencies (US$) of Sao Tome and Principe and Aid flow from UN agencies (US$) of Sudan?
Offer a very short reply. -5.31e+06. What is the ratio of the Aid flow from UN agencies (US$) in High income: OECD in 1978 to that in 1979?
Your response must be concise. 0.82. What is the ratio of the Aid flow from UN agencies (US$) of Rwanda in 1978 to that in 1979?
Your answer should be very brief. 0.58. What is the ratio of the Aid flow from UN agencies (US$) of Sao Tome and Principe in 1978 to that in 1979?
Your answer should be very brief. 1.65. What is the ratio of the Aid flow from UN agencies (US$) of Sudan in 1978 to that in 1979?
Give a very brief answer. 0.71. What is the ratio of the Aid flow from UN agencies (US$) in High income: OECD in 1978 to that in 1980?
Provide a short and direct response. 0.96. What is the ratio of the Aid flow from UN agencies (US$) of Rwanda in 1978 to that in 1980?
Provide a succinct answer. 0.28. What is the ratio of the Aid flow from UN agencies (US$) in Sao Tome and Principe in 1978 to that in 1980?
Ensure brevity in your answer.  1.26. What is the ratio of the Aid flow from UN agencies (US$) in Sudan in 1978 to that in 1980?
Ensure brevity in your answer.  0.89. What is the ratio of the Aid flow from UN agencies (US$) of High income: OECD in 1978 to that in 1982?
Your response must be concise. 0.25. What is the ratio of the Aid flow from UN agencies (US$) of Rwanda in 1978 to that in 1982?
Offer a terse response. 0.57. What is the ratio of the Aid flow from UN agencies (US$) in Sao Tome and Principe in 1978 to that in 1982?
Ensure brevity in your answer.  1.26. What is the ratio of the Aid flow from UN agencies (US$) of Sudan in 1978 to that in 1982?
Give a very brief answer. 0.95. What is the ratio of the Aid flow from UN agencies (US$) of High income: OECD in 1978 to that in 1990?
Keep it short and to the point. 0.2. What is the ratio of the Aid flow from UN agencies (US$) of Rwanda in 1978 to that in 1990?
Keep it short and to the point. 0.37. What is the ratio of the Aid flow from UN agencies (US$) in Sao Tome and Principe in 1978 to that in 1990?
Provide a succinct answer. 0.13. What is the ratio of the Aid flow from UN agencies (US$) of Sudan in 1978 to that in 1990?
Provide a short and direct response. 0.25. What is the ratio of the Aid flow from UN agencies (US$) in High income: OECD in 1978 to that in 1991?
Offer a terse response. 3.12. What is the ratio of the Aid flow from UN agencies (US$) of Rwanda in 1978 to that in 1991?
Provide a succinct answer. 0.23. What is the ratio of the Aid flow from UN agencies (US$) in Sao Tome and Principe in 1978 to that in 1991?
Your answer should be very brief. 0.2. What is the ratio of the Aid flow from UN agencies (US$) in Sudan in 1978 to that in 1991?
Your response must be concise. 0.08. What is the ratio of the Aid flow from UN agencies (US$) of Rwanda in 1978 to that in 2003?
Provide a succinct answer. 0.11. What is the ratio of the Aid flow from UN agencies (US$) in Sao Tome and Principe in 1978 to that in 2003?
Your answer should be compact. 0.7. What is the ratio of the Aid flow from UN agencies (US$) in Sudan in 1978 to that in 2003?
Your answer should be very brief. 1.59. What is the ratio of the Aid flow from UN agencies (US$) in High income: OECD in 1979 to that in 1980?
Your answer should be very brief. 1.17. What is the ratio of the Aid flow from UN agencies (US$) in Rwanda in 1979 to that in 1980?
Offer a very short reply. 0.48. What is the ratio of the Aid flow from UN agencies (US$) in Sao Tome and Principe in 1979 to that in 1980?
Give a very brief answer. 0.76. What is the ratio of the Aid flow from UN agencies (US$) of Sudan in 1979 to that in 1980?
Your answer should be very brief. 1.26. What is the ratio of the Aid flow from UN agencies (US$) of High income: OECD in 1979 to that in 1982?
Your answer should be compact. 0.3. What is the ratio of the Aid flow from UN agencies (US$) in Rwanda in 1979 to that in 1982?
Your answer should be compact. 0.98. What is the ratio of the Aid flow from UN agencies (US$) of Sao Tome and Principe in 1979 to that in 1982?
Offer a terse response. 0.76. What is the ratio of the Aid flow from UN agencies (US$) in Sudan in 1979 to that in 1982?
Keep it short and to the point. 1.35. What is the ratio of the Aid flow from UN agencies (US$) in High income: OECD in 1979 to that in 1990?
Offer a terse response. 0.24. What is the ratio of the Aid flow from UN agencies (US$) of Rwanda in 1979 to that in 1990?
Ensure brevity in your answer.  0.65. What is the ratio of the Aid flow from UN agencies (US$) of Sao Tome and Principe in 1979 to that in 1990?
Give a very brief answer. 0.08. What is the ratio of the Aid flow from UN agencies (US$) in Sudan in 1979 to that in 1990?
Give a very brief answer. 0.35. What is the ratio of the Aid flow from UN agencies (US$) in High income: OECD in 1979 to that in 1991?
Your answer should be very brief. 3.83. What is the ratio of the Aid flow from UN agencies (US$) in Rwanda in 1979 to that in 1991?
Offer a very short reply. 0.4. What is the ratio of the Aid flow from UN agencies (US$) in Sao Tome and Principe in 1979 to that in 1991?
Offer a very short reply. 0.12. What is the ratio of the Aid flow from UN agencies (US$) of Sudan in 1979 to that in 1991?
Provide a short and direct response. 0.12. What is the ratio of the Aid flow from UN agencies (US$) of High income: OECD in 1979 to that in 2003?
Offer a very short reply. 95.67. What is the ratio of the Aid flow from UN agencies (US$) in Rwanda in 1979 to that in 2003?
Your answer should be very brief. 0.19. What is the ratio of the Aid flow from UN agencies (US$) in Sao Tome and Principe in 1979 to that in 2003?
Your answer should be very brief. 0.43. What is the ratio of the Aid flow from UN agencies (US$) of Sudan in 1979 to that in 2003?
Make the answer very short. 2.25. What is the ratio of the Aid flow from UN agencies (US$) of High income: OECD in 1980 to that in 1982?
Offer a terse response. 0.26. What is the ratio of the Aid flow from UN agencies (US$) in Rwanda in 1980 to that in 1982?
Give a very brief answer. 2.05. What is the ratio of the Aid flow from UN agencies (US$) in Sudan in 1980 to that in 1982?
Offer a terse response. 1.07. What is the ratio of the Aid flow from UN agencies (US$) in High income: OECD in 1980 to that in 1990?
Make the answer very short. 0.21. What is the ratio of the Aid flow from UN agencies (US$) in Rwanda in 1980 to that in 1990?
Your response must be concise. 1.35. What is the ratio of the Aid flow from UN agencies (US$) in Sao Tome and Principe in 1980 to that in 1990?
Ensure brevity in your answer.  0.1. What is the ratio of the Aid flow from UN agencies (US$) in Sudan in 1980 to that in 1990?
Ensure brevity in your answer.  0.28. What is the ratio of the Aid flow from UN agencies (US$) in High income: OECD in 1980 to that in 1991?
Offer a very short reply. 3.27. What is the ratio of the Aid flow from UN agencies (US$) of Rwanda in 1980 to that in 1991?
Offer a very short reply. 0.83. What is the ratio of the Aid flow from UN agencies (US$) in Sao Tome and Principe in 1980 to that in 1991?
Give a very brief answer. 0.16. What is the ratio of the Aid flow from UN agencies (US$) in Sudan in 1980 to that in 1991?
Give a very brief answer. 0.09. What is the ratio of the Aid flow from UN agencies (US$) in High income: OECD in 1980 to that in 2003?
Your answer should be compact. 81.67. What is the ratio of the Aid flow from UN agencies (US$) of Rwanda in 1980 to that in 2003?
Give a very brief answer. 0.39. What is the ratio of the Aid flow from UN agencies (US$) of Sao Tome and Principe in 1980 to that in 2003?
Keep it short and to the point. 0.56. What is the ratio of the Aid flow from UN agencies (US$) in Sudan in 1980 to that in 2003?
Your answer should be compact. 1.78. What is the ratio of the Aid flow from UN agencies (US$) of High income: OECD in 1982 to that in 1990?
Your answer should be compact. 0.79. What is the ratio of the Aid flow from UN agencies (US$) of Rwanda in 1982 to that in 1990?
Your answer should be compact. 0.66. What is the ratio of the Aid flow from UN agencies (US$) of Sao Tome and Principe in 1982 to that in 1990?
Keep it short and to the point. 0.1. What is the ratio of the Aid flow from UN agencies (US$) in Sudan in 1982 to that in 1990?
Your answer should be compact. 0.26. What is the ratio of the Aid flow from UN agencies (US$) in High income: OECD in 1982 to that in 1991?
Ensure brevity in your answer.  12.61. What is the ratio of the Aid flow from UN agencies (US$) in Rwanda in 1982 to that in 1991?
Offer a terse response. 0.4. What is the ratio of the Aid flow from UN agencies (US$) of Sao Tome and Principe in 1982 to that in 1991?
Make the answer very short. 0.16. What is the ratio of the Aid flow from UN agencies (US$) in Sudan in 1982 to that in 1991?
Provide a short and direct response. 0.09. What is the ratio of the Aid flow from UN agencies (US$) in High income: OECD in 1982 to that in 2003?
Give a very brief answer. 315.33. What is the ratio of the Aid flow from UN agencies (US$) in Rwanda in 1982 to that in 2003?
Give a very brief answer. 0.19. What is the ratio of the Aid flow from UN agencies (US$) in Sao Tome and Principe in 1982 to that in 2003?
Provide a succinct answer. 0.56. What is the ratio of the Aid flow from UN agencies (US$) in Sudan in 1982 to that in 2003?
Offer a very short reply. 1.66. What is the ratio of the Aid flow from UN agencies (US$) of High income: OECD in 1990 to that in 1991?
Your answer should be very brief. 15.87. What is the ratio of the Aid flow from UN agencies (US$) in Rwanda in 1990 to that in 1991?
Ensure brevity in your answer.  0.62. What is the ratio of the Aid flow from UN agencies (US$) of Sao Tome and Principe in 1990 to that in 1991?
Your answer should be very brief. 1.54. What is the ratio of the Aid flow from UN agencies (US$) in Sudan in 1990 to that in 1991?
Keep it short and to the point. 0.33. What is the ratio of the Aid flow from UN agencies (US$) of High income: OECD in 1990 to that in 2003?
Offer a very short reply. 396.83. What is the ratio of the Aid flow from UN agencies (US$) of Rwanda in 1990 to that in 2003?
Your answer should be very brief. 0.29. What is the ratio of the Aid flow from UN agencies (US$) of Sao Tome and Principe in 1990 to that in 2003?
Keep it short and to the point. 5.31. What is the ratio of the Aid flow from UN agencies (US$) of Sudan in 1990 to that in 2003?
Provide a succinct answer. 6.36. What is the ratio of the Aid flow from UN agencies (US$) of High income: OECD in 1991 to that in 2003?
Make the answer very short. 25. What is the ratio of the Aid flow from UN agencies (US$) in Rwanda in 1991 to that in 2003?
Offer a very short reply. 0.47. What is the ratio of the Aid flow from UN agencies (US$) of Sao Tome and Principe in 1991 to that in 2003?
Keep it short and to the point. 3.46. What is the ratio of the Aid flow from UN agencies (US$) in Sudan in 1991 to that in 2003?
Your response must be concise. 19.43. What is the difference between the highest and the second highest Aid flow from UN agencies (US$) of High income: OECD?
Your response must be concise. 4.89e+06. What is the difference between the highest and the second highest Aid flow from UN agencies (US$) of Rwanda?
Your answer should be very brief. 3.52e+06. What is the difference between the highest and the second highest Aid flow from UN agencies (US$) in Sao Tome and Principe?
Give a very brief answer. 1.13e+06. What is the difference between the highest and the second highest Aid flow from UN agencies (US$) of Sudan?
Give a very brief answer. 7.74e+07. What is the difference between the highest and the lowest Aid flow from UN agencies (US$) in High income: OECD?
Your response must be concise. 2.38e+07. What is the difference between the highest and the lowest Aid flow from UN agencies (US$) in Rwanda?
Give a very brief answer. 5.96e+06. What is the difference between the highest and the lowest Aid flow from UN agencies (US$) of Sao Tome and Principe?
Make the answer very short. 2.98e+06. What is the difference between the highest and the lowest Aid flow from UN agencies (US$) in Sudan?
Provide a succinct answer. 1.09e+08. 